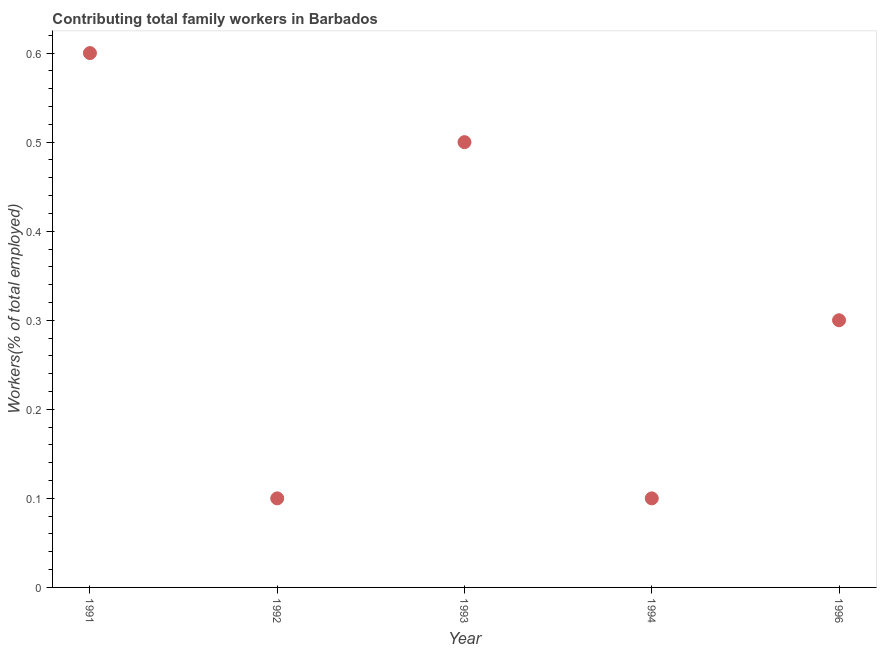What is the contributing family workers in 1996?
Your answer should be very brief. 0.3. Across all years, what is the maximum contributing family workers?
Offer a terse response. 0.6. Across all years, what is the minimum contributing family workers?
Provide a short and direct response. 0.1. In which year was the contributing family workers maximum?
Give a very brief answer. 1991. What is the sum of the contributing family workers?
Offer a terse response. 1.6. What is the difference between the contributing family workers in 1993 and 1994?
Provide a succinct answer. 0.4. What is the average contributing family workers per year?
Ensure brevity in your answer.  0.32. What is the median contributing family workers?
Your answer should be compact. 0.3. In how many years, is the contributing family workers greater than 0.1 %?
Offer a very short reply. 5. What is the ratio of the contributing family workers in 1993 to that in 1996?
Your answer should be compact. 1.67. Is the difference between the contributing family workers in 1991 and 1992 greater than the difference between any two years?
Offer a very short reply. Yes. What is the difference between the highest and the second highest contributing family workers?
Your response must be concise. 0.1. Is the sum of the contributing family workers in 1993 and 1994 greater than the maximum contributing family workers across all years?
Make the answer very short. No. What is the difference between the highest and the lowest contributing family workers?
Offer a terse response. 0.5. In how many years, is the contributing family workers greater than the average contributing family workers taken over all years?
Give a very brief answer. 2. Does the contributing family workers monotonically increase over the years?
Your answer should be compact. No. Are the values on the major ticks of Y-axis written in scientific E-notation?
Your answer should be compact. No. Does the graph contain grids?
Give a very brief answer. No. What is the title of the graph?
Your answer should be very brief. Contributing total family workers in Barbados. What is the label or title of the X-axis?
Make the answer very short. Year. What is the label or title of the Y-axis?
Offer a terse response. Workers(% of total employed). What is the Workers(% of total employed) in 1991?
Your answer should be compact. 0.6. What is the Workers(% of total employed) in 1992?
Your answer should be compact. 0.1. What is the Workers(% of total employed) in 1993?
Provide a succinct answer. 0.5. What is the Workers(% of total employed) in 1994?
Keep it short and to the point. 0.1. What is the Workers(% of total employed) in 1996?
Your response must be concise. 0.3. What is the difference between the Workers(% of total employed) in 1991 and 1992?
Your response must be concise. 0.5. What is the difference between the Workers(% of total employed) in 1991 and 1996?
Provide a succinct answer. 0.3. What is the difference between the Workers(% of total employed) in 1992 and 1993?
Ensure brevity in your answer.  -0.4. What is the difference between the Workers(% of total employed) in 1992 and 1996?
Keep it short and to the point. -0.2. What is the difference between the Workers(% of total employed) in 1993 and 1994?
Offer a very short reply. 0.4. What is the difference between the Workers(% of total employed) in 1993 and 1996?
Provide a succinct answer. 0.2. What is the ratio of the Workers(% of total employed) in 1991 to that in 1992?
Your answer should be compact. 6. What is the ratio of the Workers(% of total employed) in 1991 to that in 1994?
Keep it short and to the point. 6. What is the ratio of the Workers(% of total employed) in 1991 to that in 1996?
Offer a terse response. 2. What is the ratio of the Workers(% of total employed) in 1992 to that in 1993?
Make the answer very short. 0.2. What is the ratio of the Workers(% of total employed) in 1992 to that in 1996?
Make the answer very short. 0.33. What is the ratio of the Workers(% of total employed) in 1993 to that in 1994?
Your answer should be compact. 5. What is the ratio of the Workers(% of total employed) in 1993 to that in 1996?
Provide a succinct answer. 1.67. What is the ratio of the Workers(% of total employed) in 1994 to that in 1996?
Your response must be concise. 0.33. 